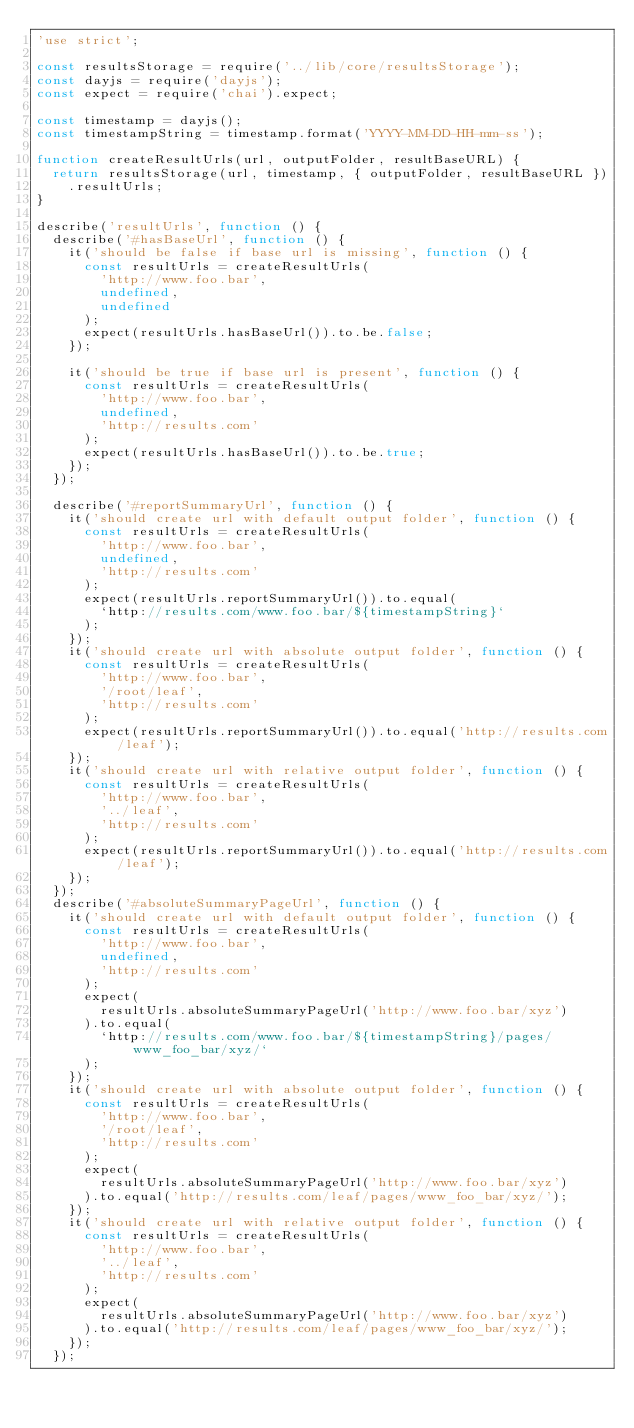<code> <loc_0><loc_0><loc_500><loc_500><_JavaScript_>'use strict';

const resultsStorage = require('../lib/core/resultsStorage');
const dayjs = require('dayjs');
const expect = require('chai').expect;

const timestamp = dayjs();
const timestampString = timestamp.format('YYYY-MM-DD-HH-mm-ss');

function createResultUrls(url, outputFolder, resultBaseURL) {
  return resultsStorage(url, timestamp, { outputFolder, resultBaseURL })
    .resultUrls;
}

describe('resultUrls', function () {
  describe('#hasBaseUrl', function () {
    it('should be false if base url is missing', function () {
      const resultUrls = createResultUrls(
        'http://www.foo.bar',
        undefined,
        undefined
      );
      expect(resultUrls.hasBaseUrl()).to.be.false;
    });

    it('should be true if base url is present', function () {
      const resultUrls = createResultUrls(
        'http://www.foo.bar',
        undefined,
        'http://results.com'
      );
      expect(resultUrls.hasBaseUrl()).to.be.true;
    });
  });

  describe('#reportSummaryUrl', function () {
    it('should create url with default output folder', function () {
      const resultUrls = createResultUrls(
        'http://www.foo.bar',
        undefined,
        'http://results.com'
      );
      expect(resultUrls.reportSummaryUrl()).to.equal(
        `http://results.com/www.foo.bar/${timestampString}`
      );
    });
    it('should create url with absolute output folder', function () {
      const resultUrls = createResultUrls(
        'http://www.foo.bar',
        '/root/leaf',
        'http://results.com'
      );
      expect(resultUrls.reportSummaryUrl()).to.equal('http://results.com/leaf');
    });
    it('should create url with relative output folder', function () {
      const resultUrls = createResultUrls(
        'http://www.foo.bar',
        '../leaf',
        'http://results.com'
      );
      expect(resultUrls.reportSummaryUrl()).to.equal('http://results.com/leaf');
    });
  });
  describe('#absoluteSummaryPageUrl', function () {
    it('should create url with default output folder', function () {
      const resultUrls = createResultUrls(
        'http://www.foo.bar',
        undefined,
        'http://results.com'
      );
      expect(
        resultUrls.absoluteSummaryPageUrl('http://www.foo.bar/xyz')
      ).to.equal(
        `http://results.com/www.foo.bar/${timestampString}/pages/www_foo_bar/xyz/`
      );
    });
    it('should create url with absolute output folder', function () {
      const resultUrls = createResultUrls(
        'http://www.foo.bar',
        '/root/leaf',
        'http://results.com'
      );
      expect(
        resultUrls.absoluteSummaryPageUrl('http://www.foo.bar/xyz')
      ).to.equal('http://results.com/leaf/pages/www_foo_bar/xyz/');
    });
    it('should create url with relative output folder', function () {
      const resultUrls = createResultUrls(
        'http://www.foo.bar',
        '../leaf',
        'http://results.com'
      );
      expect(
        resultUrls.absoluteSummaryPageUrl('http://www.foo.bar/xyz')
      ).to.equal('http://results.com/leaf/pages/www_foo_bar/xyz/');
    });
  });</code> 